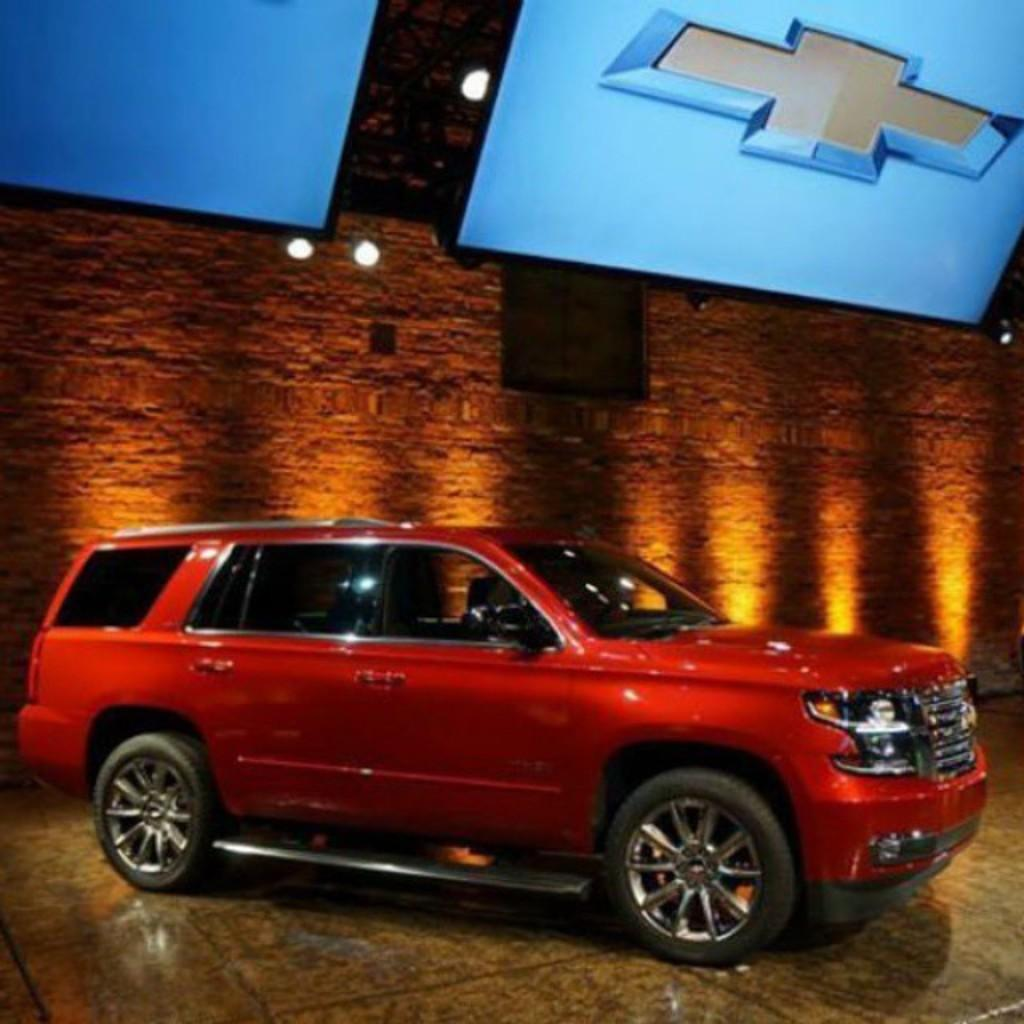What is the main subject in the center of the image? There is a car in the center of the image. What can be seen in the background of the image? There is a wall in the background of the image. What is at the bottom of the image? There is a floor at the bottom of the image. What is located at the top of the image? There are two televisions at the top of the image. What type of mice can be seen running around the car in the image? There are no mice present in the image; it only features a car, a wall, a floor, and two televisions. 